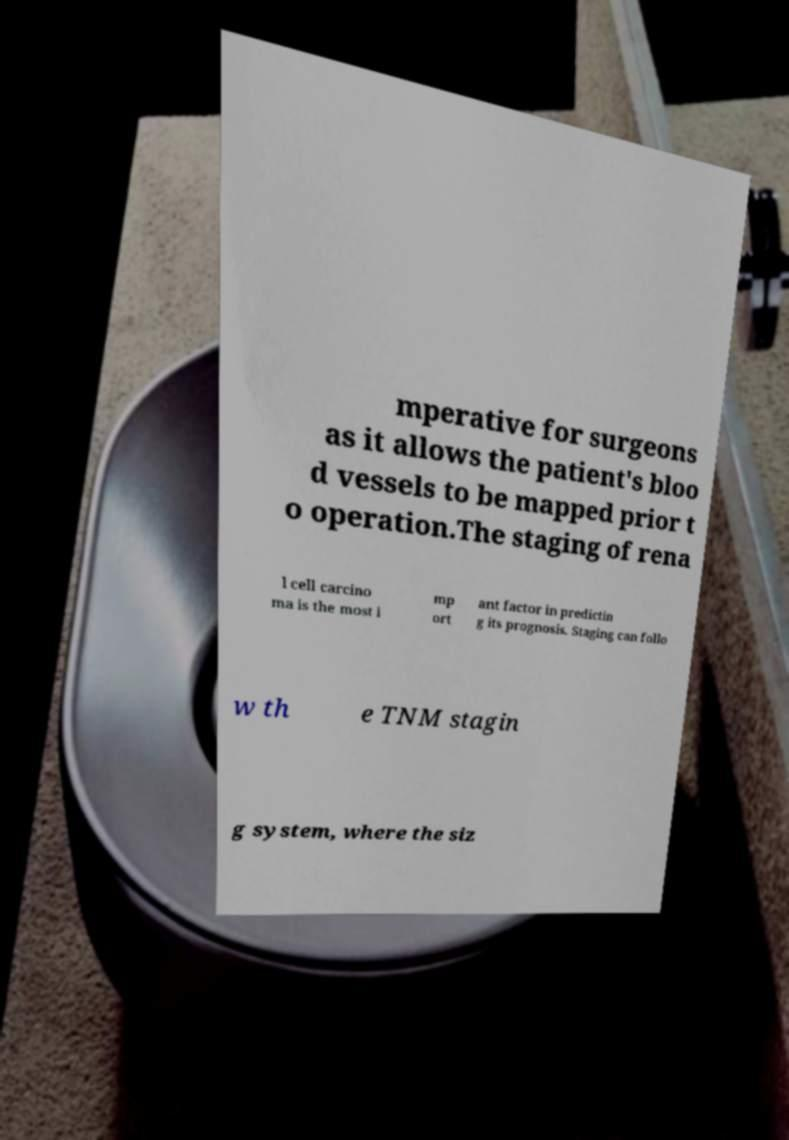Can you accurately transcribe the text from the provided image for me? mperative for surgeons as it allows the patient's bloo d vessels to be mapped prior t o operation.The staging of rena l cell carcino ma is the most i mp ort ant factor in predictin g its prognosis. Staging can follo w th e TNM stagin g system, where the siz 